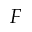<formula> <loc_0><loc_0><loc_500><loc_500>F</formula> 